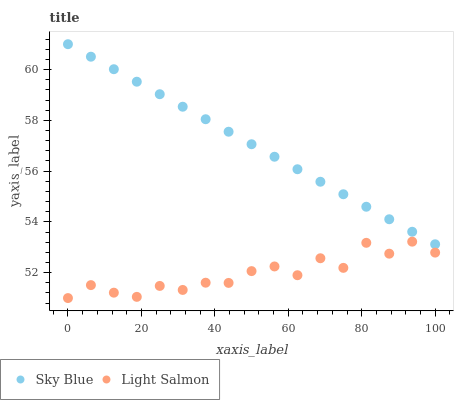Does Light Salmon have the minimum area under the curve?
Answer yes or no. Yes. Does Sky Blue have the maximum area under the curve?
Answer yes or no. Yes. Does Light Salmon have the maximum area under the curve?
Answer yes or no. No. Is Sky Blue the smoothest?
Answer yes or no. Yes. Is Light Salmon the roughest?
Answer yes or no. Yes. Is Light Salmon the smoothest?
Answer yes or no. No. Does Light Salmon have the lowest value?
Answer yes or no. Yes. Does Sky Blue have the highest value?
Answer yes or no. Yes. Does Light Salmon have the highest value?
Answer yes or no. No. Is Light Salmon less than Sky Blue?
Answer yes or no. Yes. Is Sky Blue greater than Light Salmon?
Answer yes or no. Yes. Does Light Salmon intersect Sky Blue?
Answer yes or no. No. 